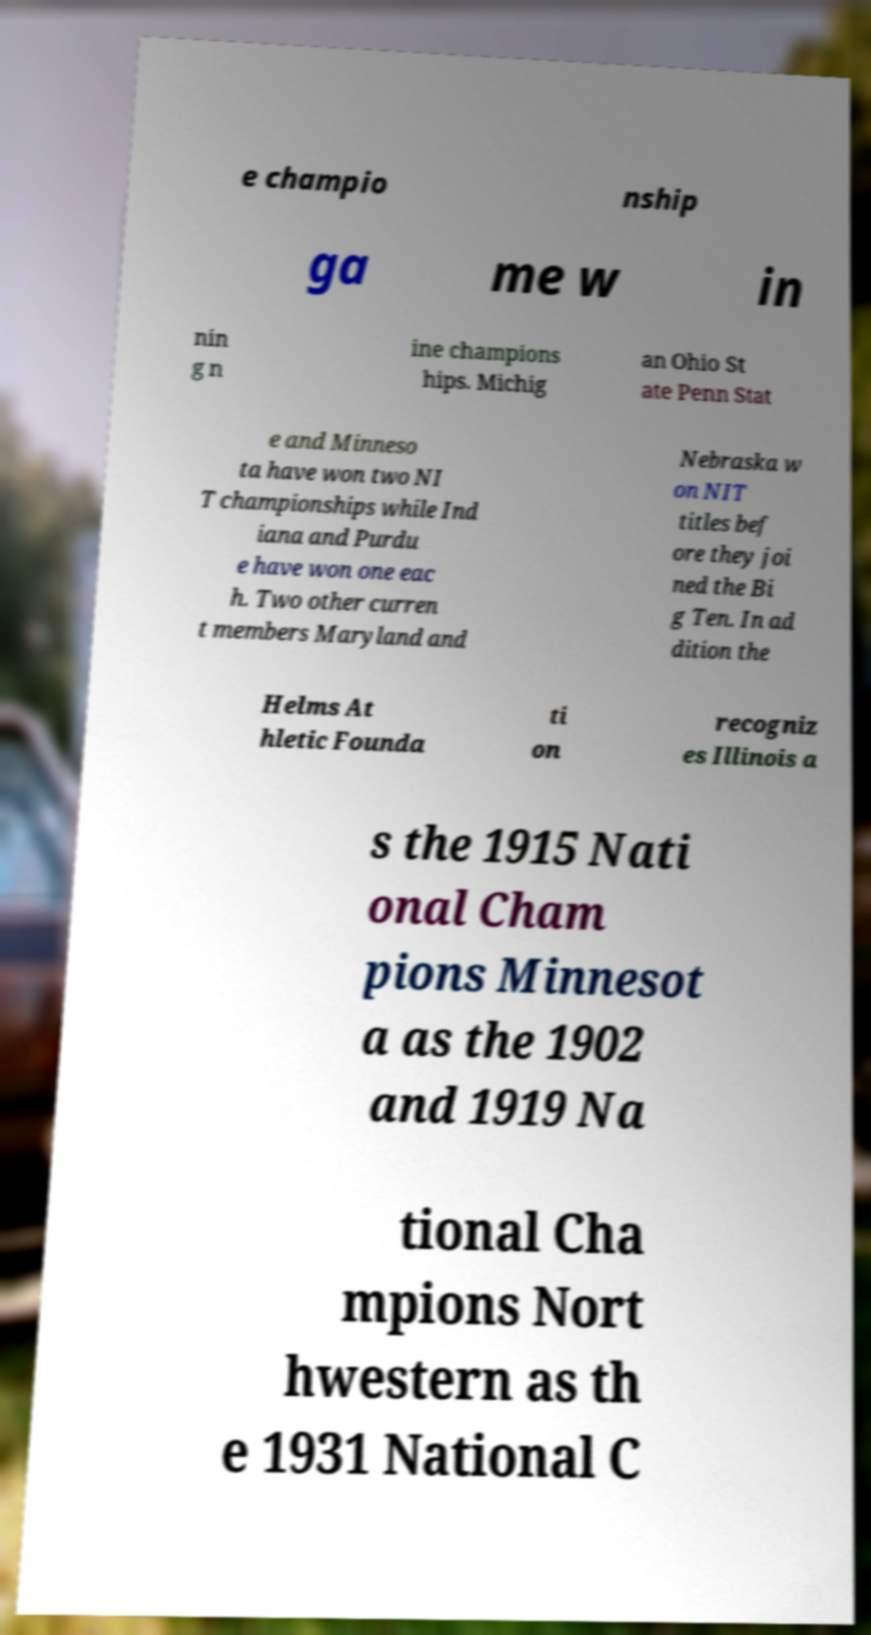There's text embedded in this image that I need extracted. Can you transcribe it verbatim? e champio nship ga me w in nin g n ine champions hips. Michig an Ohio St ate Penn Stat e and Minneso ta have won two NI T championships while Ind iana and Purdu e have won one eac h. Two other curren t members Maryland and Nebraska w on NIT titles bef ore they joi ned the Bi g Ten. In ad dition the Helms At hletic Founda ti on recogniz es Illinois a s the 1915 Nati onal Cham pions Minnesot a as the 1902 and 1919 Na tional Cha mpions Nort hwestern as th e 1931 National C 